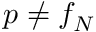<formula> <loc_0><loc_0><loc_500><loc_500>p \neq f _ { N }</formula> 